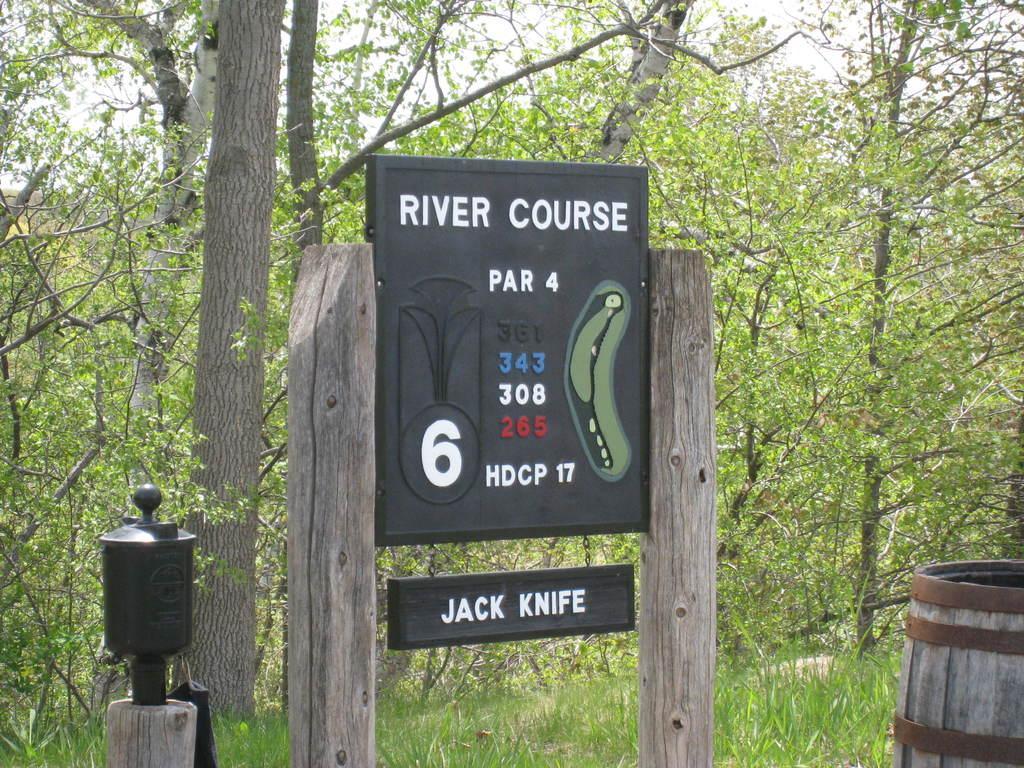Please provide a concise description of this image. In the picture we can see a board to the wooden poles and on it we can see written as river course and beside it, we can see a wooden drum and behind the board we can see some grass plants and trees. 